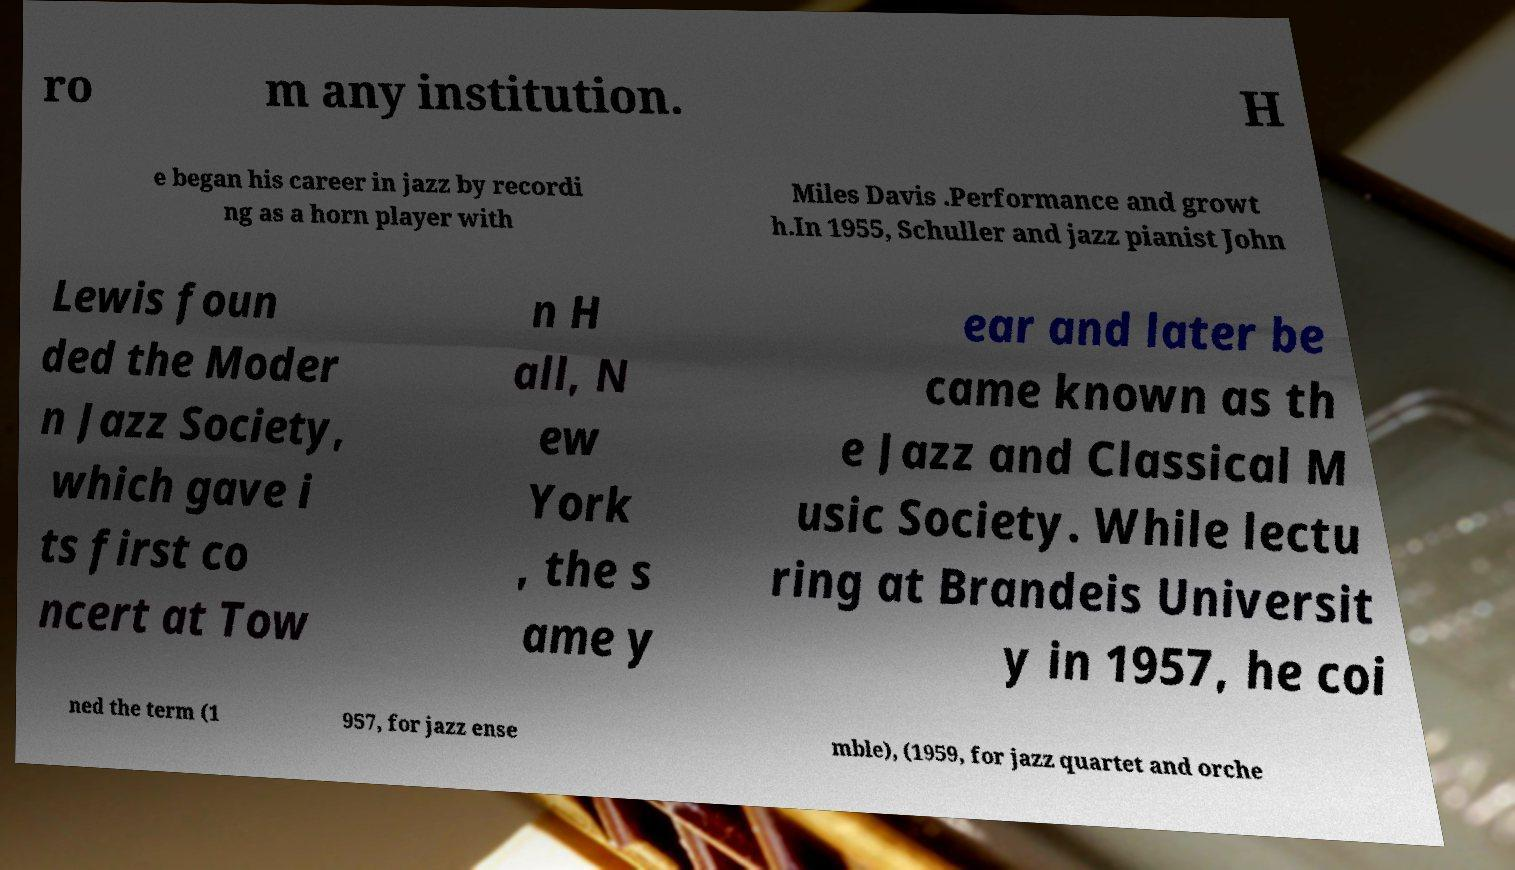Please read and relay the text visible in this image. What does it say? ro m any institution. H e began his career in jazz by recordi ng as a horn player with Miles Davis .Performance and growt h.In 1955, Schuller and jazz pianist John Lewis foun ded the Moder n Jazz Society, which gave i ts first co ncert at Tow n H all, N ew York , the s ame y ear and later be came known as th e Jazz and Classical M usic Society. While lectu ring at Brandeis Universit y in 1957, he coi ned the term (1 957, for jazz ense mble), (1959, for jazz quartet and orche 